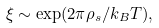<formula> <loc_0><loc_0><loc_500><loc_500>\xi \sim \exp ( 2 \pi \rho _ { s } / k _ { B } T ) ,</formula> 